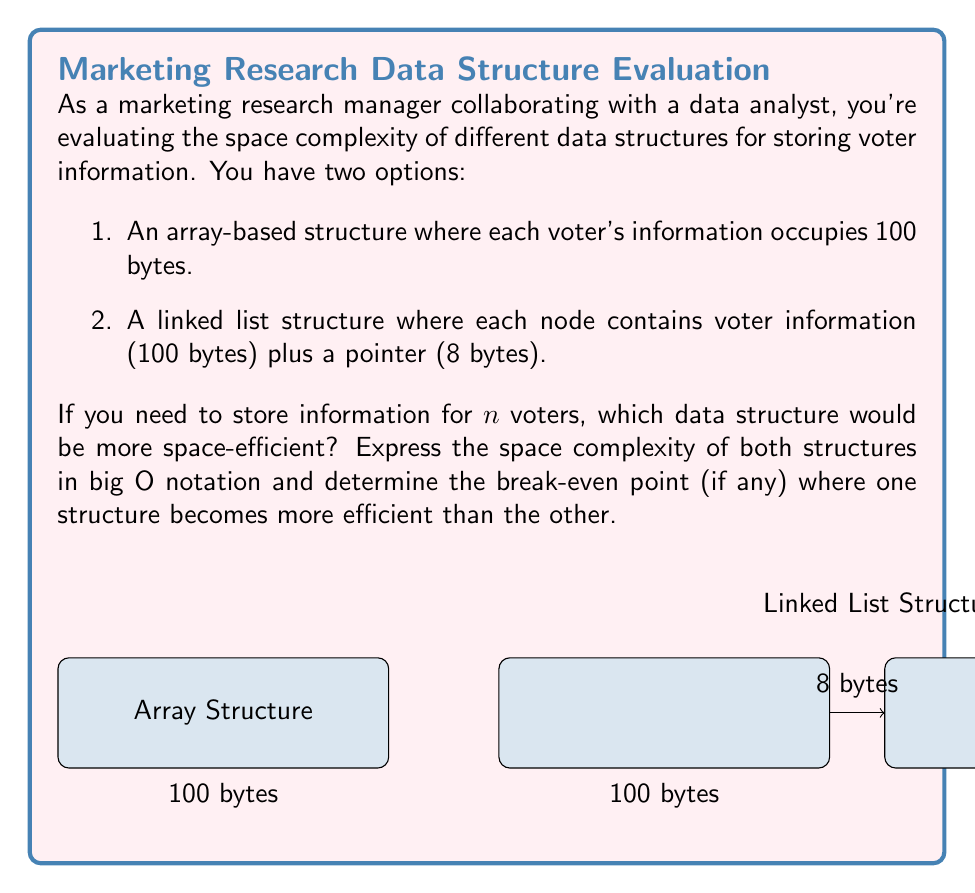Show me your answer to this math problem. Let's approach this step-by-step:

1) For the array-based structure:
   - Each voter's information occupies 100 bytes
   - For n voters, the total space required is $100n$ bytes
   - The space complexity is $O(n)$

2) For the linked list structure:
   - Each node contains 100 bytes of voter information plus 8 bytes for the pointer
   - For n voters, the total space required is $(100 + 8)n = 108n$ bytes
   - The space complexity is also $O(n)$

3) To find the break-even point, we set up the equation:
   $100n = 108n$

4) Solving this equation:
   $100n = 108n$
   $0 = 8n$
   $n = 0$

5) This means that for any positive number of voters, the array-based structure will always be more space-efficient.

6) To quantify the difference:
   - Array structure: $100n$ bytes
   - Linked list structure: $108n$ bytes
   - Difference: $108n - 100n = 8n$ bytes

Therefore, the array-based structure saves 8 bytes per voter compared to the linked list structure.
Answer: Array-based structure is always more space-efficient. Both have $O(n)$ complexity, but array uses $8n$ fewer bytes. 